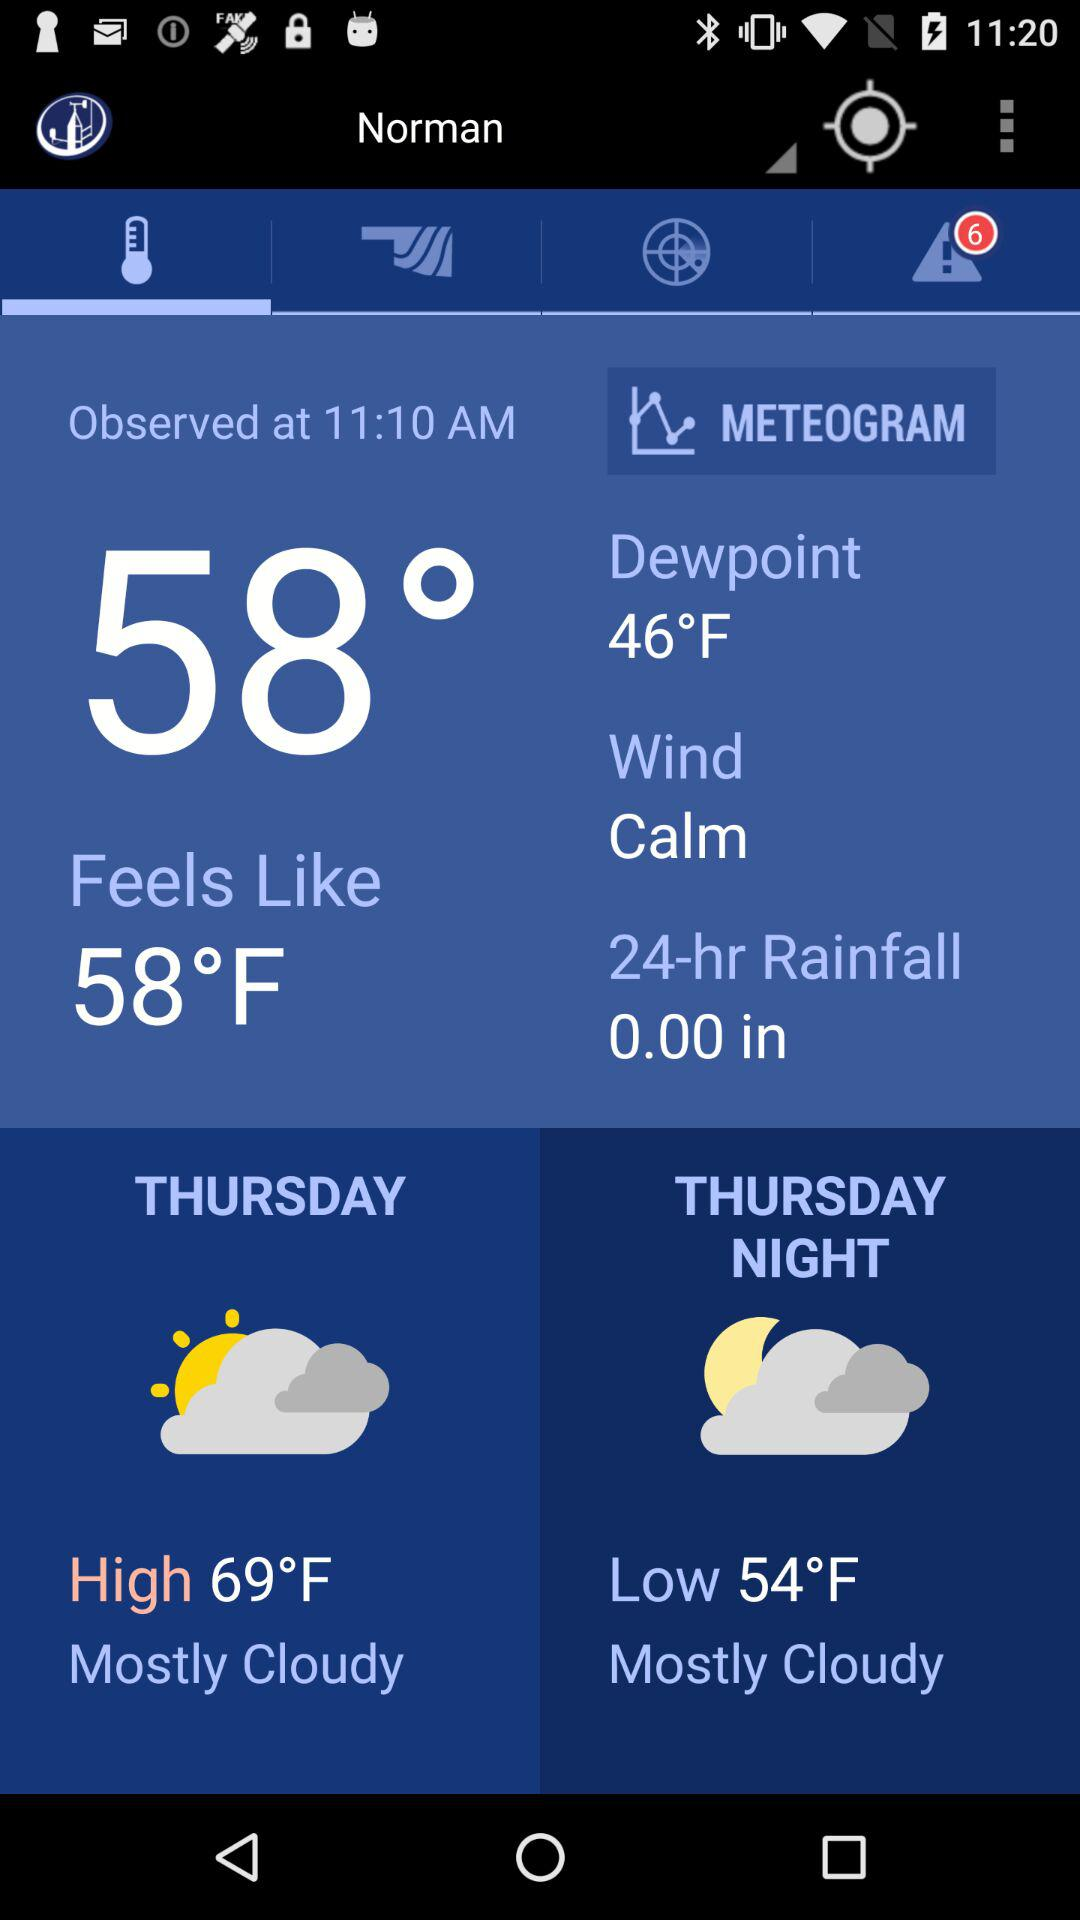What is the temperature? The temperature is 58 degrees. 